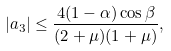<formula> <loc_0><loc_0><loc_500><loc_500>| a _ { 3 } | \leq \frac { 4 ( 1 - \alpha ) \cos \beta } { ( 2 + \mu ) ( 1 + \mu ) } ,</formula> 